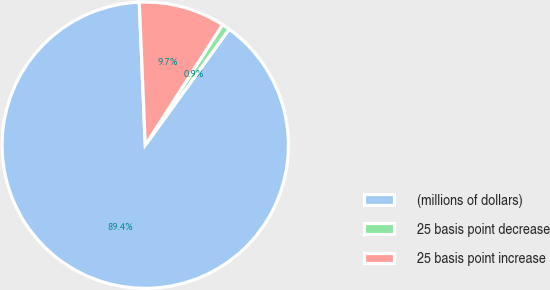Convert chart. <chart><loc_0><loc_0><loc_500><loc_500><pie_chart><fcel>(millions of dollars)<fcel>25 basis point decrease<fcel>25 basis point increase<nl><fcel>89.37%<fcel>0.89%<fcel>9.74%<nl></chart> 